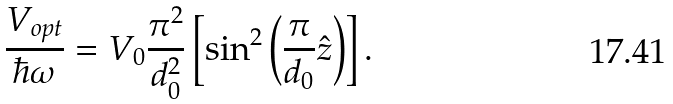Convert formula to latex. <formula><loc_0><loc_0><loc_500><loc_500>\frac { V _ { o p t } } { \hbar { \omega } } = V _ { 0 } \frac { \pi ^ { 2 } } { d _ { 0 } ^ { 2 } } \left [ \sin ^ { 2 } \left ( \frac { \pi } { d _ { 0 } } \hat { z } \right ) \right ] .</formula> 